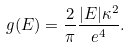Convert formula to latex. <formula><loc_0><loc_0><loc_500><loc_500>g ( E ) = \frac { 2 } { \pi } \frac { | E | \kappa ^ { 2 } } { e ^ { 4 } } .</formula> 